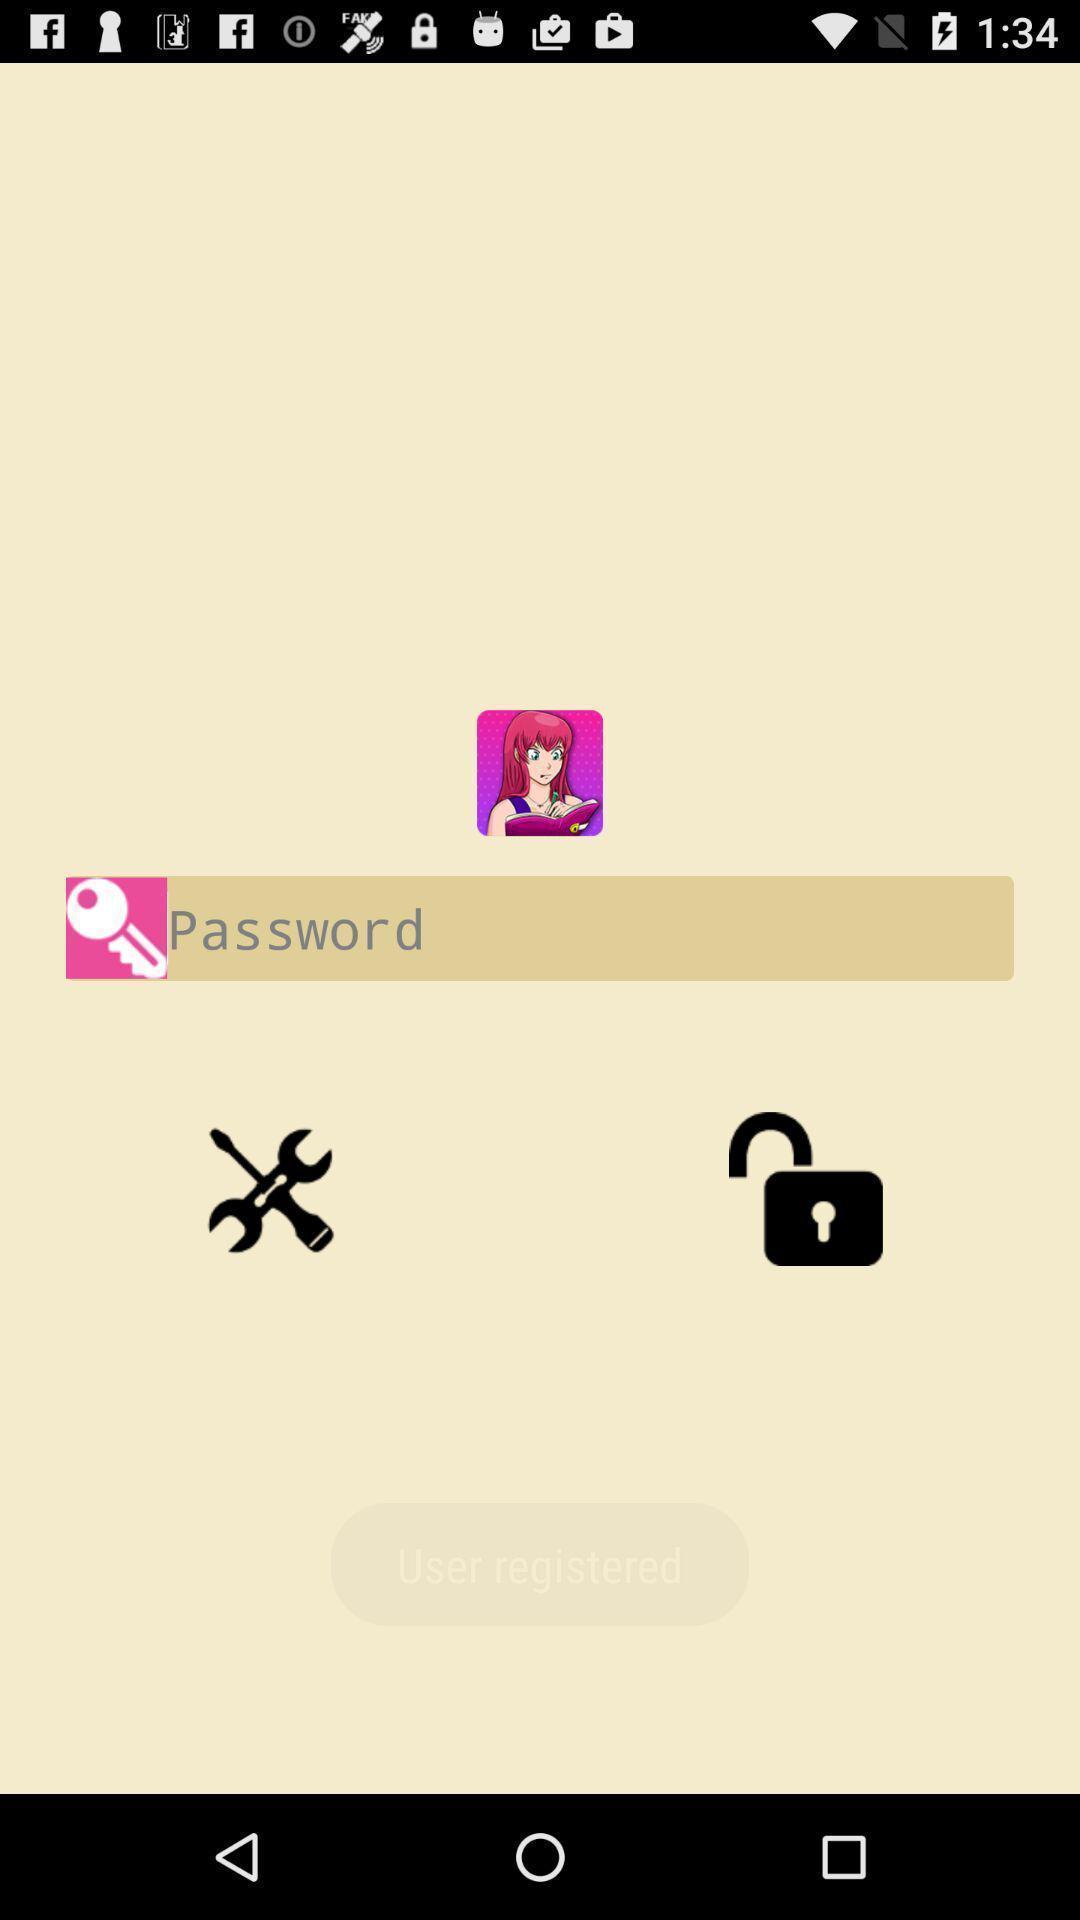Summarize the main components in this picture. Page displaying to enter the details. 